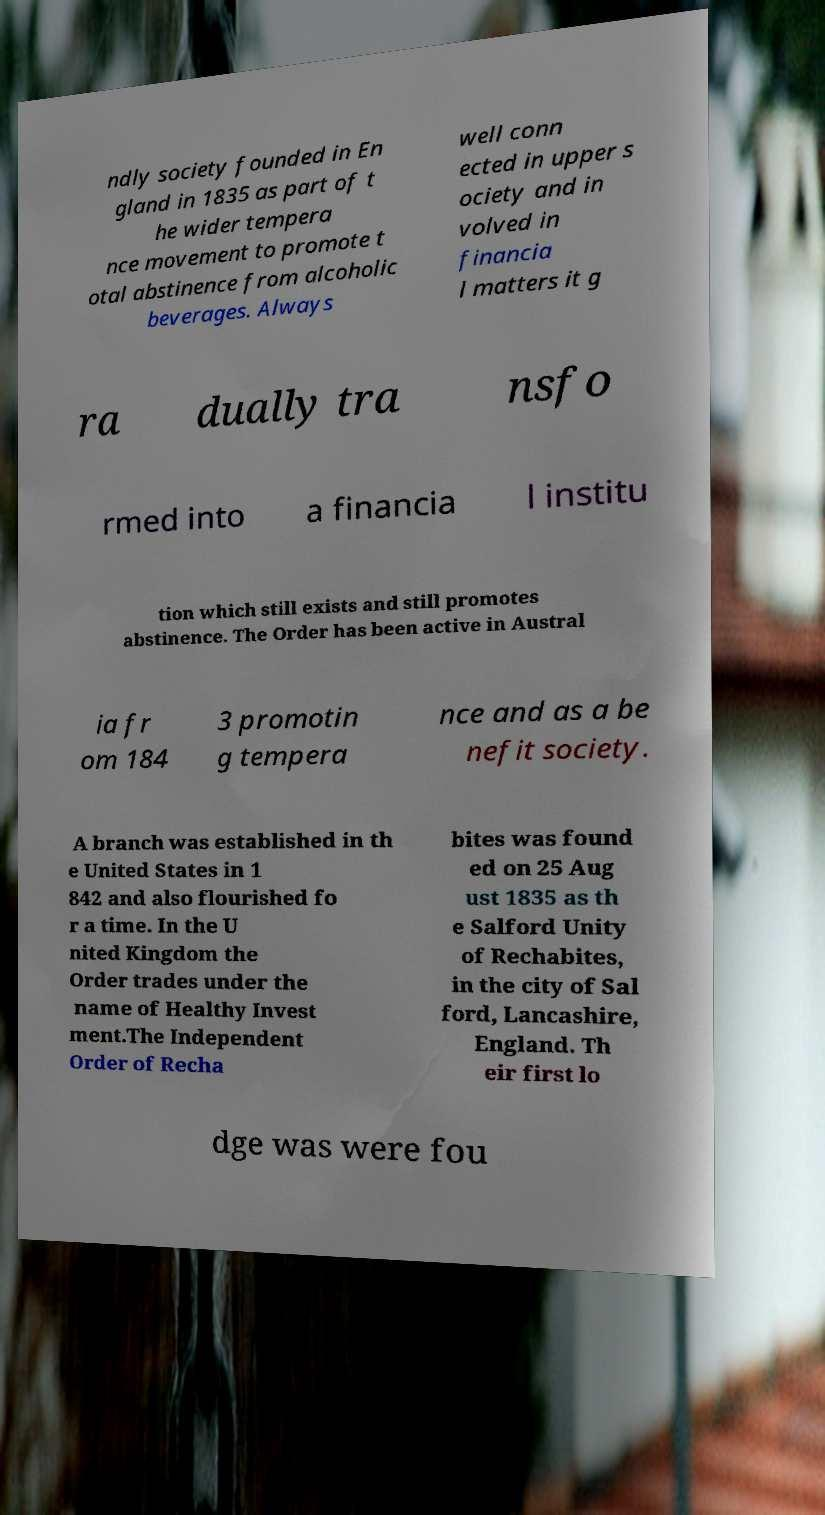Please identify and transcribe the text found in this image. ndly society founded in En gland in 1835 as part of t he wider tempera nce movement to promote t otal abstinence from alcoholic beverages. Always well conn ected in upper s ociety and in volved in financia l matters it g ra dually tra nsfo rmed into a financia l institu tion which still exists and still promotes abstinence. The Order has been active in Austral ia fr om 184 3 promotin g tempera nce and as a be nefit society. A branch was established in th e United States in 1 842 and also flourished fo r a time. In the U nited Kingdom the Order trades under the name of Healthy Invest ment.The Independent Order of Recha bites was found ed on 25 Aug ust 1835 as th e Salford Unity of Rechabites, in the city of Sal ford, Lancashire, England. Th eir first lo dge was were fou 